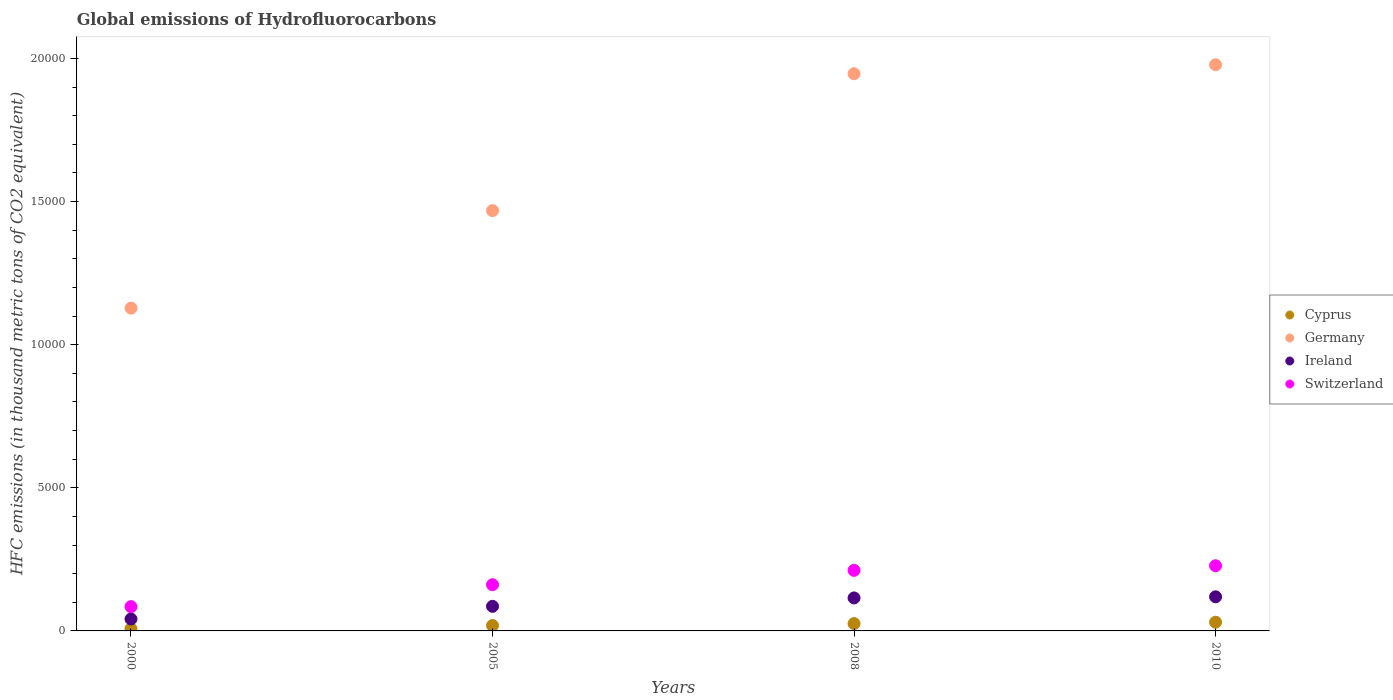Is the number of dotlines equal to the number of legend labels?
Your answer should be compact. Yes. What is the global emissions of Hydrofluorocarbons in Cyprus in 2010?
Your answer should be very brief. 304. Across all years, what is the maximum global emissions of Hydrofluorocarbons in Ireland?
Give a very brief answer. 1192. Across all years, what is the minimum global emissions of Hydrofluorocarbons in Germany?
Keep it short and to the point. 1.13e+04. In which year was the global emissions of Hydrofluorocarbons in Switzerland minimum?
Offer a very short reply. 2000. What is the total global emissions of Hydrofluorocarbons in Germany in the graph?
Your answer should be compact. 6.52e+04. What is the difference between the global emissions of Hydrofluorocarbons in Germany in 2000 and that in 2005?
Ensure brevity in your answer.  -3407. What is the difference between the global emissions of Hydrofluorocarbons in Switzerland in 2005 and the global emissions of Hydrofluorocarbons in Ireland in 2008?
Give a very brief answer. 461.2. What is the average global emissions of Hydrofluorocarbons in Cyprus per year?
Provide a succinct answer. 206.7. In the year 2008, what is the difference between the global emissions of Hydrofluorocarbons in Cyprus and global emissions of Hydrofluorocarbons in Germany?
Offer a terse response. -1.92e+04. What is the ratio of the global emissions of Hydrofluorocarbons in Cyprus in 2005 to that in 2008?
Give a very brief answer. 0.74. What is the difference between the highest and the second highest global emissions of Hydrofluorocarbons in Ireland?
Provide a succinct answer. 39.4. What is the difference between the highest and the lowest global emissions of Hydrofluorocarbons in Switzerland?
Your response must be concise. 1428.8. Does the global emissions of Hydrofluorocarbons in Switzerland monotonically increase over the years?
Offer a terse response. Yes. Is the global emissions of Hydrofluorocarbons in Switzerland strictly greater than the global emissions of Hydrofluorocarbons in Germany over the years?
Your answer should be compact. No. Is the global emissions of Hydrofluorocarbons in Germany strictly less than the global emissions of Hydrofluorocarbons in Cyprus over the years?
Keep it short and to the point. No. How many dotlines are there?
Make the answer very short. 4. What is the difference between two consecutive major ticks on the Y-axis?
Provide a short and direct response. 5000. Where does the legend appear in the graph?
Your response must be concise. Center right. How are the legend labels stacked?
Make the answer very short. Vertical. What is the title of the graph?
Your answer should be compact. Global emissions of Hydrofluorocarbons. What is the label or title of the X-axis?
Offer a terse response. Years. What is the label or title of the Y-axis?
Provide a succinct answer. HFC emissions (in thousand metric tons of CO2 equivalent). What is the HFC emissions (in thousand metric tons of CO2 equivalent) in Cyprus in 2000?
Make the answer very short. 78.4. What is the HFC emissions (in thousand metric tons of CO2 equivalent) of Germany in 2000?
Offer a terse response. 1.13e+04. What is the HFC emissions (in thousand metric tons of CO2 equivalent) in Ireland in 2000?
Provide a succinct answer. 416.3. What is the HFC emissions (in thousand metric tons of CO2 equivalent) in Switzerland in 2000?
Your answer should be compact. 848.2. What is the HFC emissions (in thousand metric tons of CO2 equivalent) of Cyprus in 2005?
Your answer should be compact. 188.3. What is the HFC emissions (in thousand metric tons of CO2 equivalent) in Germany in 2005?
Your answer should be very brief. 1.47e+04. What is the HFC emissions (in thousand metric tons of CO2 equivalent) in Ireland in 2005?
Provide a short and direct response. 859.7. What is the HFC emissions (in thousand metric tons of CO2 equivalent) in Switzerland in 2005?
Give a very brief answer. 1613.8. What is the HFC emissions (in thousand metric tons of CO2 equivalent) in Cyprus in 2008?
Ensure brevity in your answer.  256.1. What is the HFC emissions (in thousand metric tons of CO2 equivalent) in Germany in 2008?
Keep it short and to the point. 1.95e+04. What is the HFC emissions (in thousand metric tons of CO2 equivalent) of Ireland in 2008?
Keep it short and to the point. 1152.6. What is the HFC emissions (in thousand metric tons of CO2 equivalent) in Switzerland in 2008?
Offer a terse response. 2116.4. What is the HFC emissions (in thousand metric tons of CO2 equivalent) in Cyprus in 2010?
Your response must be concise. 304. What is the HFC emissions (in thousand metric tons of CO2 equivalent) of Germany in 2010?
Offer a terse response. 1.98e+04. What is the HFC emissions (in thousand metric tons of CO2 equivalent) in Ireland in 2010?
Give a very brief answer. 1192. What is the HFC emissions (in thousand metric tons of CO2 equivalent) in Switzerland in 2010?
Keep it short and to the point. 2277. Across all years, what is the maximum HFC emissions (in thousand metric tons of CO2 equivalent) in Cyprus?
Offer a very short reply. 304. Across all years, what is the maximum HFC emissions (in thousand metric tons of CO2 equivalent) in Germany?
Your answer should be very brief. 1.98e+04. Across all years, what is the maximum HFC emissions (in thousand metric tons of CO2 equivalent) of Ireland?
Ensure brevity in your answer.  1192. Across all years, what is the maximum HFC emissions (in thousand metric tons of CO2 equivalent) of Switzerland?
Ensure brevity in your answer.  2277. Across all years, what is the minimum HFC emissions (in thousand metric tons of CO2 equivalent) in Cyprus?
Give a very brief answer. 78.4. Across all years, what is the minimum HFC emissions (in thousand metric tons of CO2 equivalent) in Germany?
Keep it short and to the point. 1.13e+04. Across all years, what is the minimum HFC emissions (in thousand metric tons of CO2 equivalent) of Ireland?
Keep it short and to the point. 416.3. Across all years, what is the minimum HFC emissions (in thousand metric tons of CO2 equivalent) of Switzerland?
Make the answer very short. 848.2. What is the total HFC emissions (in thousand metric tons of CO2 equivalent) in Cyprus in the graph?
Your answer should be compact. 826.8. What is the total HFC emissions (in thousand metric tons of CO2 equivalent) of Germany in the graph?
Provide a succinct answer. 6.52e+04. What is the total HFC emissions (in thousand metric tons of CO2 equivalent) in Ireland in the graph?
Provide a succinct answer. 3620.6. What is the total HFC emissions (in thousand metric tons of CO2 equivalent) of Switzerland in the graph?
Your response must be concise. 6855.4. What is the difference between the HFC emissions (in thousand metric tons of CO2 equivalent) of Cyprus in 2000 and that in 2005?
Your answer should be very brief. -109.9. What is the difference between the HFC emissions (in thousand metric tons of CO2 equivalent) in Germany in 2000 and that in 2005?
Your response must be concise. -3407. What is the difference between the HFC emissions (in thousand metric tons of CO2 equivalent) of Ireland in 2000 and that in 2005?
Keep it short and to the point. -443.4. What is the difference between the HFC emissions (in thousand metric tons of CO2 equivalent) in Switzerland in 2000 and that in 2005?
Offer a very short reply. -765.6. What is the difference between the HFC emissions (in thousand metric tons of CO2 equivalent) in Cyprus in 2000 and that in 2008?
Give a very brief answer. -177.7. What is the difference between the HFC emissions (in thousand metric tons of CO2 equivalent) in Germany in 2000 and that in 2008?
Offer a terse response. -8189.2. What is the difference between the HFC emissions (in thousand metric tons of CO2 equivalent) in Ireland in 2000 and that in 2008?
Make the answer very short. -736.3. What is the difference between the HFC emissions (in thousand metric tons of CO2 equivalent) in Switzerland in 2000 and that in 2008?
Your answer should be very brief. -1268.2. What is the difference between the HFC emissions (in thousand metric tons of CO2 equivalent) of Cyprus in 2000 and that in 2010?
Provide a short and direct response. -225.6. What is the difference between the HFC emissions (in thousand metric tons of CO2 equivalent) in Germany in 2000 and that in 2010?
Your answer should be very brief. -8502.4. What is the difference between the HFC emissions (in thousand metric tons of CO2 equivalent) in Ireland in 2000 and that in 2010?
Keep it short and to the point. -775.7. What is the difference between the HFC emissions (in thousand metric tons of CO2 equivalent) of Switzerland in 2000 and that in 2010?
Provide a succinct answer. -1428.8. What is the difference between the HFC emissions (in thousand metric tons of CO2 equivalent) in Cyprus in 2005 and that in 2008?
Keep it short and to the point. -67.8. What is the difference between the HFC emissions (in thousand metric tons of CO2 equivalent) of Germany in 2005 and that in 2008?
Make the answer very short. -4782.2. What is the difference between the HFC emissions (in thousand metric tons of CO2 equivalent) of Ireland in 2005 and that in 2008?
Keep it short and to the point. -292.9. What is the difference between the HFC emissions (in thousand metric tons of CO2 equivalent) in Switzerland in 2005 and that in 2008?
Provide a succinct answer. -502.6. What is the difference between the HFC emissions (in thousand metric tons of CO2 equivalent) in Cyprus in 2005 and that in 2010?
Your answer should be compact. -115.7. What is the difference between the HFC emissions (in thousand metric tons of CO2 equivalent) in Germany in 2005 and that in 2010?
Offer a very short reply. -5095.4. What is the difference between the HFC emissions (in thousand metric tons of CO2 equivalent) in Ireland in 2005 and that in 2010?
Keep it short and to the point. -332.3. What is the difference between the HFC emissions (in thousand metric tons of CO2 equivalent) of Switzerland in 2005 and that in 2010?
Give a very brief answer. -663.2. What is the difference between the HFC emissions (in thousand metric tons of CO2 equivalent) in Cyprus in 2008 and that in 2010?
Give a very brief answer. -47.9. What is the difference between the HFC emissions (in thousand metric tons of CO2 equivalent) of Germany in 2008 and that in 2010?
Your response must be concise. -313.2. What is the difference between the HFC emissions (in thousand metric tons of CO2 equivalent) in Ireland in 2008 and that in 2010?
Ensure brevity in your answer.  -39.4. What is the difference between the HFC emissions (in thousand metric tons of CO2 equivalent) of Switzerland in 2008 and that in 2010?
Provide a succinct answer. -160.6. What is the difference between the HFC emissions (in thousand metric tons of CO2 equivalent) of Cyprus in 2000 and the HFC emissions (in thousand metric tons of CO2 equivalent) of Germany in 2005?
Provide a short and direct response. -1.46e+04. What is the difference between the HFC emissions (in thousand metric tons of CO2 equivalent) in Cyprus in 2000 and the HFC emissions (in thousand metric tons of CO2 equivalent) in Ireland in 2005?
Keep it short and to the point. -781.3. What is the difference between the HFC emissions (in thousand metric tons of CO2 equivalent) of Cyprus in 2000 and the HFC emissions (in thousand metric tons of CO2 equivalent) of Switzerland in 2005?
Provide a succinct answer. -1535.4. What is the difference between the HFC emissions (in thousand metric tons of CO2 equivalent) in Germany in 2000 and the HFC emissions (in thousand metric tons of CO2 equivalent) in Ireland in 2005?
Make the answer very short. 1.04e+04. What is the difference between the HFC emissions (in thousand metric tons of CO2 equivalent) in Germany in 2000 and the HFC emissions (in thousand metric tons of CO2 equivalent) in Switzerland in 2005?
Give a very brief answer. 9663.8. What is the difference between the HFC emissions (in thousand metric tons of CO2 equivalent) in Ireland in 2000 and the HFC emissions (in thousand metric tons of CO2 equivalent) in Switzerland in 2005?
Your response must be concise. -1197.5. What is the difference between the HFC emissions (in thousand metric tons of CO2 equivalent) of Cyprus in 2000 and the HFC emissions (in thousand metric tons of CO2 equivalent) of Germany in 2008?
Offer a terse response. -1.94e+04. What is the difference between the HFC emissions (in thousand metric tons of CO2 equivalent) of Cyprus in 2000 and the HFC emissions (in thousand metric tons of CO2 equivalent) of Ireland in 2008?
Provide a succinct answer. -1074.2. What is the difference between the HFC emissions (in thousand metric tons of CO2 equivalent) of Cyprus in 2000 and the HFC emissions (in thousand metric tons of CO2 equivalent) of Switzerland in 2008?
Ensure brevity in your answer.  -2038. What is the difference between the HFC emissions (in thousand metric tons of CO2 equivalent) in Germany in 2000 and the HFC emissions (in thousand metric tons of CO2 equivalent) in Ireland in 2008?
Offer a terse response. 1.01e+04. What is the difference between the HFC emissions (in thousand metric tons of CO2 equivalent) in Germany in 2000 and the HFC emissions (in thousand metric tons of CO2 equivalent) in Switzerland in 2008?
Keep it short and to the point. 9161.2. What is the difference between the HFC emissions (in thousand metric tons of CO2 equivalent) in Ireland in 2000 and the HFC emissions (in thousand metric tons of CO2 equivalent) in Switzerland in 2008?
Your answer should be very brief. -1700.1. What is the difference between the HFC emissions (in thousand metric tons of CO2 equivalent) in Cyprus in 2000 and the HFC emissions (in thousand metric tons of CO2 equivalent) in Germany in 2010?
Your answer should be very brief. -1.97e+04. What is the difference between the HFC emissions (in thousand metric tons of CO2 equivalent) in Cyprus in 2000 and the HFC emissions (in thousand metric tons of CO2 equivalent) in Ireland in 2010?
Your answer should be very brief. -1113.6. What is the difference between the HFC emissions (in thousand metric tons of CO2 equivalent) of Cyprus in 2000 and the HFC emissions (in thousand metric tons of CO2 equivalent) of Switzerland in 2010?
Provide a short and direct response. -2198.6. What is the difference between the HFC emissions (in thousand metric tons of CO2 equivalent) of Germany in 2000 and the HFC emissions (in thousand metric tons of CO2 equivalent) of Ireland in 2010?
Offer a very short reply. 1.01e+04. What is the difference between the HFC emissions (in thousand metric tons of CO2 equivalent) of Germany in 2000 and the HFC emissions (in thousand metric tons of CO2 equivalent) of Switzerland in 2010?
Provide a short and direct response. 9000.6. What is the difference between the HFC emissions (in thousand metric tons of CO2 equivalent) in Ireland in 2000 and the HFC emissions (in thousand metric tons of CO2 equivalent) in Switzerland in 2010?
Keep it short and to the point. -1860.7. What is the difference between the HFC emissions (in thousand metric tons of CO2 equivalent) of Cyprus in 2005 and the HFC emissions (in thousand metric tons of CO2 equivalent) of Germany in 2008?
Make the answer very short. -1.93e+04. What is the difference between the HFC emissions (in thousand metric tons of CO2 equivalent) of Cyprus in 2005 and the HFC emissions (in thousand metric tons of CO2 equivalent) of Ireland in 2008?
Your response must be concise. -964.3. What is the difference between the HFC emissions (in thousand metric tons of CO2 equivalent) in Cyprus in 2005 and the HFC emissions (in thousand metric tons of CO2 equivalent) in Switzerland in 2008?
Provide a succinct answer. -1928.1. What is the difference between the HFC emissions (in thousand metric tons of CO2 equivalent) in Germany in 2005 and the HFC emissions (in thousand metric tons of CO2 equivalent) in Ireland in 2008?
Ensure brevity in your answer.  1.35e+04. What is the difference between the HFC emissions (in thousand metric tons of CO2 equivalent) of Germany in 2005 and the HFC emissions (in thousand metric tons of CO2 equivalent) of Switzerland in 2008?
Ensure brevity in your answer.  1.26e+04. What is the difference between the HFC emissions (in thousand metric tons of CO2 equivalent) in Ireland in 2005 and the HFC emissions (in thousand metric tons of CO2 equivalent) in Switzerland in 2008?
Make the answer very short. -1256.7. What is the difference between the HFC emissions (in thousand metric tons of CO2 equivalent) of Cyprus in 2005 and the HFC emissions (in thousand metric tons of CO2 equivalent) of Germany in 2010?
Offer a very short reply. -1.96e+04. What is the difference between the HFC emissions (in thousand metric tons of CO2 equivalent) in Cyprus in 2005 and the HFC emissions (in thousand metric tons of CO2 equivalent) in Ireland in 2010?
Make the answer very short. -1003.7. What is the difference between the HFC emissions (in thousand metric tons of CO2 equivalent) in Cyprus in 2005 and the HFC emissions (in thousand metric tons of CO2 equivalent) in Switzerland in 2010?
Give a very brief answer. -2088.7. What is the difference between the HFC emissions (in thousand metric tons of CO2 equivalent) in Germany in 2005 and the HFC emissions (in thousand metric tons of CO2 equivalent) in Ireland in 2010?
Provide a succinct answer. 1.35e+04. What is the difference between the HFC emissions (in thousand metric tons of CO2 equivalent) of Germany in 2005 and the HFC emissions (in thousand metric tons of CO2 equivalent) of Switzerland in 2010?
Offer a terse response. 1.24e+04. What is the difference between the HFC emissions (in thousand metric tons of CO2 equivalent) of Ireland in 2005 and the HFC emissions (in thousand metric tons of CO2 equivalent) of Switzerland in 2010?
Your response must be concise. -1417.3. What is the difference between the HFC emissions (in thousand metric tons of CO2 equivalent) of Cyprus in 2008 and the HFC emissions (in thousand metric tons of CO2 equivalent) of Germany in 2010?
Offer a terse response. -1.95e+04. What is the difference between the HFC emissions (in thousand metric tons of CO2 equivalent) of Cyprus in 2008 and the HFC emissions (in thousand metric tons of CO2 equivalent) of Ireland in 2010?
Your answer should be very brief. -935.9. What is the difference between the HFC emissions (in thousand metric tons of CO2 equivalent) of Cyprus in 2008 and the HFC emissions (in thousand metric tons of CO2 equivalent) of Switzerland in 2010?
Offer a very short reply. -2020.9. What is the difference between the HFC emissions (in thousand metric tons of CO2 equivalent) in Germany in 2008 and the HFC emissions (in thousand metric tons of CO2 equivalent) in Ireland in 2010?
Ensure brevity in your answer.  1.83e+04. What is the difference between the HFC emissions (in thousand metric tons of CO2 equivalent) in Germany in 2008 and the HFC emissions (in thousand metric tons of CO2 equivalent) in Switzerland in 2010?
Provide a succinct answer. 1.72e+04. What is the difference between the HFC emissions (in thousand metric tons of CO2 equivalent) in Ireland in 2008 and the HFC emissions (in thousand metric tons of CO2 equivalent) in Switzerland in 2010?
Keep it short and to the point. -1124.4. What is the average HFC emissions (in thousand metric tons of CO2 equivalent) in Cyprus per year?
Offer a very short reply. 206.7. What is the average HFC emissions (in thousand metric tons of CO2 equivalent) in Germany per year?
Your response must be concise. 1.63e+04. What is the average HFC emissions (in thousand metric tons of CO2 equivalent) of Ireland per year?
Make the answer very short. 905.15. What is the average HFC emissions (in thousand metric tons of CO2 equivalent) of Switzerland per year?
Your answer should be very brief. 1713.85. In the year 2000, what is the difference between the HFC emissions (in thousand metric tons of CO2 equivalent) of Cyprus and HFC emissions (in thousand metric tons of CO2 equivalent) of Germany?
Provide a succinct answer. -1.12e+04. In the year 2000, what is the difference between the HFC emissions (in thousand metric tons of CO2 equivalent) of Cyprus and HFC emissions (in thousand metric tons of CO2 equivalent) of Ireland?
Offer a terse response. -337.9. In the year 2000, what is the difference between the HFC emissions (in thousand metric tons of CO2 equivalent) in Cyprus and HFC emissions (in thousand metric tons of CO2 equivalent) in Switzerland?
Ensure brevity in your answer.  -769.8. In the year 2000, what is the difference between the HFC emissions (in thousand metric tons of CO2 equivalent) of Germany and HFC emissions (in thousand metric tons of CO2 equivalent) of Ireland?
Keep it short and to the point. 1.09e+04. In the year 2000, what is the difference between the HFC emissions (in thousand metric tons of CO2 equivalent) in Germany and HFC emissions (in thousand metric tons of CO2 equivalent) in Switzerland?
Offer a very short reply. 1.04e+04. In the year 2000, what is the difference between the HFC emissions (in thousand metric tons of CO2 equivalent) in Ireland and HFC emissions (in thousand metric tons of CO2 equivalent) in Switzerland?
Ensure brevity in your answer.  -431.9. In the year 2005, what is the difference between the HFC emissions (in thousand metric tons of CO2 equivalent) in Cyprus and HFC emissions (in thousand metric tons of CO2 equivalent) in Germany?
Your response must be concise. -1.45e+04. In the year 2005, what is the difference between the HFC emissions (in thousand metric tons of CO2 equivalent) of Cyprus and HFC emissions (in thousand metric tons of CO2 equivalent) of Ireland?
Offer a very short reply. -671.4. In the year 2005, what is the difference between the HFC emissions (in thousand metric tons of CO2 equivalent) of Cyprus and HFC emissions (in thousand metric tons of CO2 equivalent) of Switzerland?
Offer a terse response. -1425.5. In the year 2005, what is the difference between the HFC emissions (in thousand metric tons of CO2 equivalent) of Germany and HFC emissions (in thousand metric tons of CO2 equivalent) of Ireland?
Your answer should be very brief. 1.38e+04. In the year 2005, what is the difference between the HFC emissions (in thousand metric tons of CO2 equivalent) of Germany and HFC emissions (in thousand metric tons of CO2 equivalent) of Switzerland?
Ensure brevity in your answer.  1.31e+04. In the year 2005, what is the difference between the HFC emissions (in thousand metric tons of CO2 equivalent) of Ireland and HFC emissions (in thousand metric tons of CO2 equivalent) of Switzerland?
Provide a succinct answer. -754.1. In the year 2008, what is the difference between the HFC emissions (in thousand metric tons of CO2 equivalent) in Cyprus and HFC emissions (in thousand metric tons of CO2 equivalent) in Germany?
Your answer should be very brief. -1.92e+04. In the year 2008, what is the difference between the HFC emissions (in thousand metric tons of CO2 equivalent) of Cyprus and HFC emissions (in thousand metric tons of CO2 equivalent) of Ireland?
Your answer should be very brief. -896.5. In the year 2008, what is the difference between the HFC emissions (in thousand metric tons of CO2 equivalent) in Cyprus and HFC emissions (in thousand metric tons of CO2 equivalent) in Switzerland?
Provide a short and direct response. -1860.3. In the year 2008, what is the difference between the HFC emissions (in thousand metric tons of CO2 equivalent) in Germany and HFC emissions (in thousand metric tons of CO2 equivalent) in Ireland?
Offer a very short reply. 1.83e+04. In the year 2008, what is the difference between the HFC emissions (in thousand metric tons of CO2 equivalent) in Germany and HFC emissions (in thousand metric tons of CO2 equivalent) in Switzerland?
Provide a short and direct response. 1.74e+04. In the year 2008, what is the difference between the HFC emissions (in thousand metric tons of CO2 equivalent) in Ireland and HFC emissions (in thousand metric tons of CO2 equivalent) in Switzerland?
Provide a short and direct response. -963.8. In the year 2010, what is the difference between the HFC emissions (in thousand metric tons of CO2 equivalent) of Cyprus and HFC emissions (in thousand metric tons of CO2 equivalent) of Germany?
Your response must be concise. -1.95e+04. In the year 2010, what is the difference between the HFC emissions (in thousand metric tons of CO2 equivalent) of Cyprus and HFC emissions (in thousand metric tons of CO2 equivalent) of Ireland?
Your response must be concise. -888. In the year 2010, what is the difference between the HFC emissions (in thousand metric tons of CO2 equivalent) in Cyprus and HFC emissions (in thousand metric tons of CO2 equivalent) in Switzerland?
Your response must be concise. -1973. In the year 2010, what is the difference between the HFC emissions (in thousand metric tons of CO2 equivalent) in Germany and HFC emissions (in thousand metric tons of CO2 equivalent) in Ireland?
Ensure brevity in your answer.  1.86e+04. In the year 2010, what is the difference between the HFC emissions (in thousand metric tons of CO2 equivalent) in Germany and HFC emissions (in thousand metric tons of CO2 equivalent) in Switzerland?
Make the answer very short. 1.75e+04. In the year 2010, what is the difference between the HFC emissions (in thousand metric tons of CO2 equivalent) in Ireland and HFC emissions (in thousand metric tons of CO2 equivalent) in Switzerland?
Your response must be concise. -1085. What is the ratio of the HFC emissions (in thousand metric tons of CO2 equivalent) of Cyprus in 2000 to that in 2005?
Your answer should be very brief. 0.42. What is the ratio of the HFC emissions (in thousand metric tons of CO2 equivalent) of Germany in 2000 to that in 2005?
Offer a terse response. 0.77. What is the ratio of the HFC emissions (in thousand metric tons of CO2 equivalent) in Ireland in 2000 to that in 2005?
Offer a very short reply. 0.48. What is the ratio of the HFC emissions (in thousand metric tons of CO2 equivalent) in Switzerland in 2000 to that in 2005?
Provide a succinct answer. 0.53. What is the ratio of the HFC emissions (in thousand metric tons of CO2 equivalent) of Cyprus in 2000 to that in 2008?
Give a very brief answer. 0.31. What is the ratio of the HFC emissions (in thousand metric tons of CO2 equivalent) of Germany in 2000 to that in 2008?
Offer a terse response. 0.58. What is the ratio of the HFC emissions (in thousand metric tons of CO2 equivalent) of Ireland in 2000 to that in 2008?
Offer a terse response. 0.36. What is the ratio of the HFC emissions (in thousand metric tons of CO2 equivalent) of Switzerland in 2000 to that in 2008?
Provide a short and direct response. 0.4. What is the ratio of the HFC emissions (in thousand metric tons of CO2 equivalent) in Cyprus in 2000 to that in 2010?
Make the answer very short. 0.26. What is the ratio of the HFC emissions (in thousand metric tons of CO2 equivalent) of Germany in 2000 to that in 2010?
Your answer should be very brief. 0.57. What is the ratio of the HFC emissions (in thousand metric tons of CO2 equivalent) in Ireland in 2000 to that in 2010?
Ensure brevity in your answer.  0.35. What is the ratio of the HFC emissions (in thousand metric tons of CO2 equivalent) of Switzerland in 2000 to that in 2010?
Give a very brief answer. 0.37. What is the ratio of the HFC emissions (in thousand metric tons of CO2 equivalent) in Cyprus in 2005 to that in 2008?
Your answer should be compact. 0.74. What is the ratio of the HFC emissions (in thousand metric tons of CO2 equivalent) in Germany in 2005 to that in 2008?
Your response must be concise. 0.75. What is the ratio of the HFC emissions (in thousand metric tons of CO2 equivalent) in Ireland in 2005 to that in 2008?
Offer a terse response. 0.75. What is the ratio of the HFC emissions (in thousand metric tons of CO2 equivalent) in Switzerland in 2005 to that in 2008?
Your answer should be very brief. 0.76. What is the ratio of the HFC emissions (in thousand metric tons of CO2 equivalent) of Cyprus in 2005 to that in 2010?
Your answer should be very brief. 0.62. What is the ratio of the HFC emissions (in thousand metric tons of CO2 equivalent) in Germany in 2005 to that in 2010?
Your answer should be compact. 0.74. What is the ratio of the HFC emissions (in thousand metric tons of CO2 equivalent) in Ireland in 2005 to that in 2010?
Keep it short and to the point. 0.72. What is the ratio of the HFC emissions (in thousand metric tons of CO2 equivalent) in Switzerland in 2005 to that in 2010?
Your answer should be compact. 0.71. What is the ratio of the HFC emissions (in thousand metric tons of CO2 equivalent) of Cyprus in 2008 to that in 2010?
Offer a terse response. 0.84. What is the ratio of the HFC emissions (in thousand metric tons of CO2 equivalent) in Germany in 2008 to that in 2010?
Keep it short and to the point. 0.98. What is the ratio of the HFC emissions (in thousand metric tons of CO2 equivalent) of Ireland in 2008 to that in 2010?
Provide a succinct answer. 0.97. What is the ratio of the HFC emissions (in thousand metric tons of CO2 equivalent) in Switzerland in 2008 to that in 2010?
Make the answer very short. 0.93. What is the difference between the highest and the second highest HFC emissions (in thousand metric tons of CO2 equivalent) in Cyprus?
Your answer should be compact. 47.9. What is the difference between the highest and the second highest HFC emissions (in thousand metric tons of CO2 equivalent) in Germany?
Offer a terse response. 313.2. What is the difference between the highest and the second highest HFC emissions (in thousand metric tons of CO2 equivalent) of Ireland?
Make the answer very short. 39.4. What is the difference between the highest and the second highest HFC emissions (in thousand metric tons of CO2 equivalent) of Switzerland?
Keep it short and to the point. 160.6. What is the difference between the highest and the lowest HFC emissions (in thousand metric tons of CO2 equivalent) of Cyprus?
Offer a terse response. 225.6. What is the difference between the highest and the lowest HFC emissions (in thousand metric tons of CO2 equivalent) in Germany?
Provide a short and direct response. 8502.4. What is the difference between the highest and the lowest HFC emissions (in thousand metric tons of CO2 equivalent) in Ireland?
Ensure brevity in your answer.  775.7. What is the difference between the highest and the lowest HFC emissions (in thousand metric tons of CO2 equivalent) of Switzerland?
Give a very brief answer. 1428.8. 